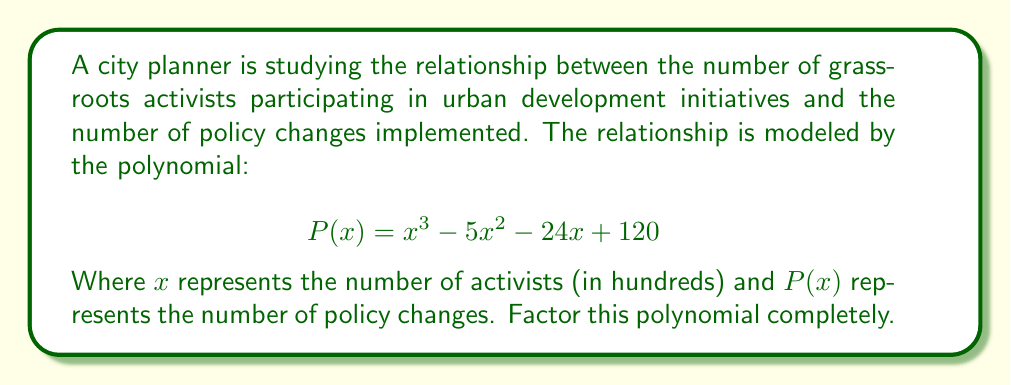Give your solution to this math problem. To factor this polynomial, we'll follow these steps:

1) First, let's check if there are any rational roots using the rational root theorem. The possible rational roots are the factors of the constant term (120): ±1, ±2, ±3, ±4, ±5, ±6, ±8, ±10, ±12, ±15, ±20, ±24, ±30, ±40, ±60, ±120.

2) Testing these values, we find that $x = 8$ is a root of the polynomial.

3) We can factor out $(x - 8)$ using polynomial long division:

   $$x^3 - 5x^2 - 24x + 120 = (x - 8)(x^2 + 3x - 15)$$

4) Now we need to factor the quadratic term $x^2 + 3x - 15$. We can do this by finding two numbers that multiply to give -15 and add to give 3.

5) These numbers are 6 and -3. So we can factor the quadratic as:

   $$(x + 6)(x - 3)$$

6) Putting it all together, our fully factored polynomial is:

   $$P(x) = (x - 8)(x + 6)(x - 3)$$

This factorization shows that the policy changes will be zero when there are 800, 300, or -600 activists. The negative value isn't realistic in this context, but the math still holds.
Answer: $(x - 8)(x + 6)(x - 3)$ 